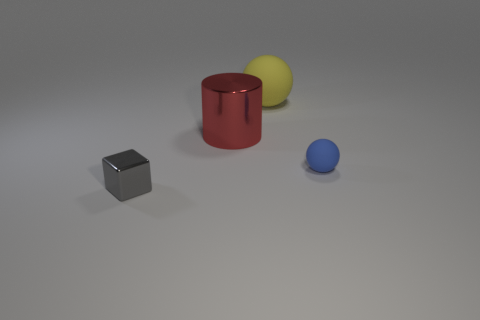Add 2 tiny blue rubber objects. How many objects exist? 6 Subtract all blue balls. How many balls are left? 1 Subtract all cylinders. How many objects are left? 3 Subtract all blue spheres. Subtract all cyan cylinders. How many spheres are left? 1 Subtract all tiny cyan metallic objects. Subtract all tiny matte spheres. How many objects are left? 3 Add 1 small cubes. How many small cubes are left? 2 Add 4 yellow things. How many yellow things exist? 5 Subtract 0 green cylinders. How many objects are left? 4 